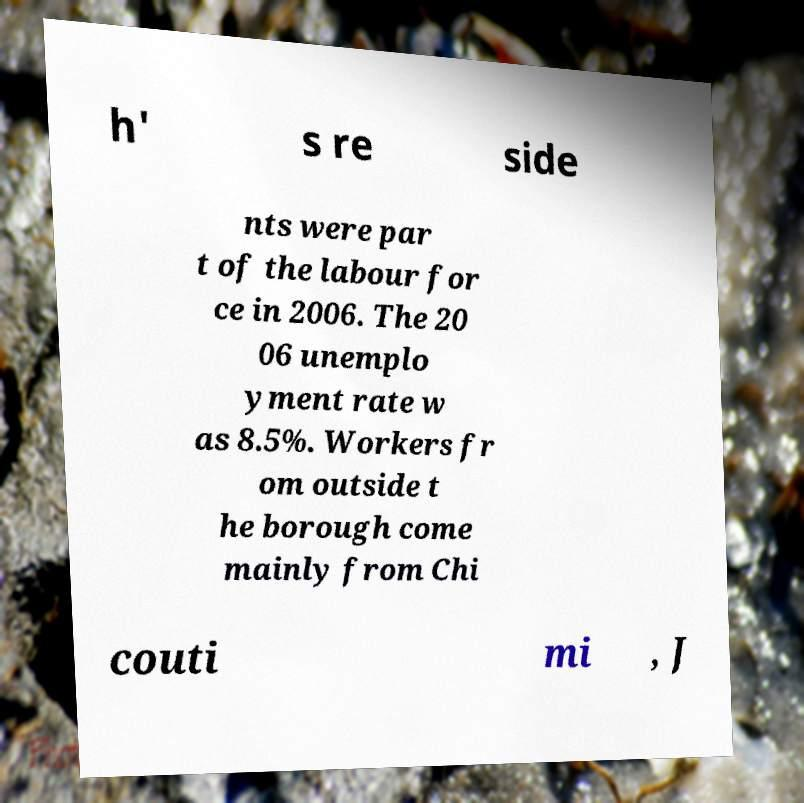Please identify and transcribe the text found in this image. h' s re side nts were par t of the labour for ce in 2006. The 20 06 unemplo yment rate w as 8.5%. Workers fr om outside t he borough come mainly from Chi couti mi , J 